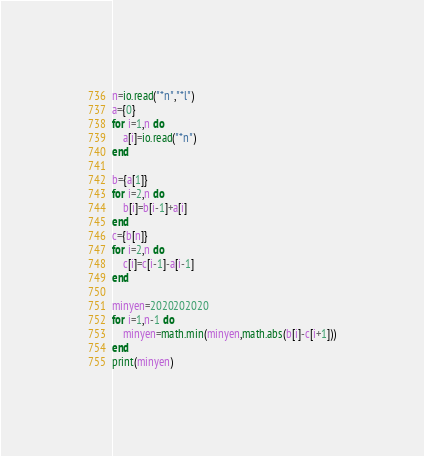Convert code to text. <code><loc_0><loc_0><loc_500><loc_500><_Lua_>n=io.read("*n","*l")
a={0}
for i=1,n do
    a[i]=io.read("*n")
end

b={a[1]}
for i=2,n do
    b[i]=b[i-1]+a[i]
end
c={b[n]}
for i=2,n do
    c[i]=c[i-1]-a[i-1]
end

minyen=2020202020
for i=1,n-1 do
    minyen=math.min(minyen,math.abs(b[i]-c[i+1]))
end
print(minyen)</code> 